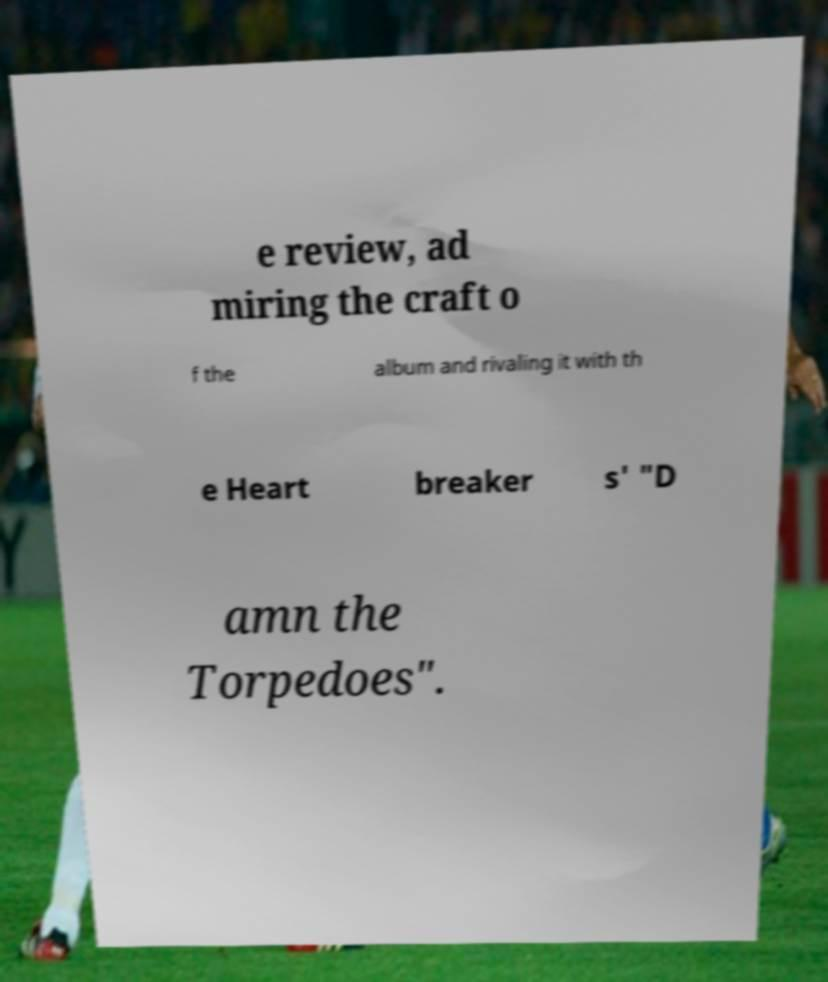Please read and relay the text visible in this image. What does it say? e review, ad miring the craft o f the album and rivaling it with th e Heart breaker s' "D amn the Torpedoes". 